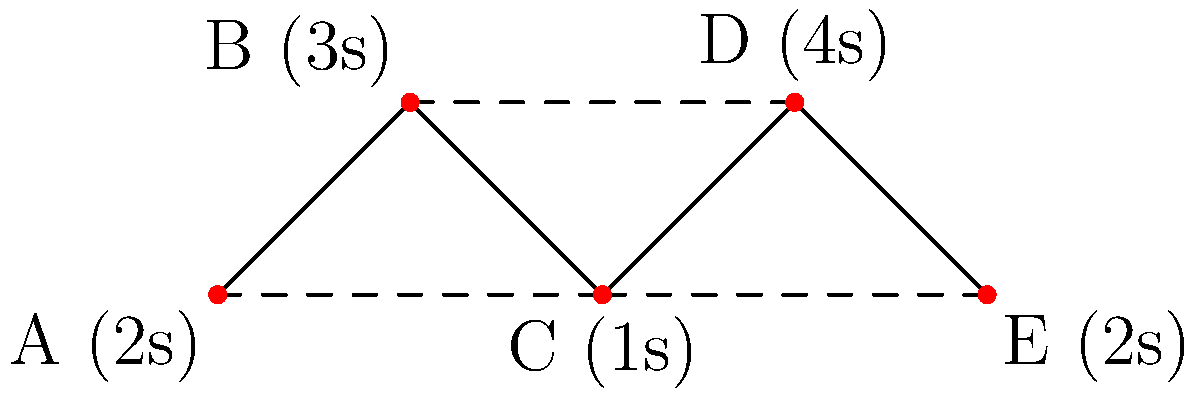Given the network graph representing a website's structure, where nodes represent pages and edges represent links between pages, and the load time for each page is given in parentheses, what is the minimum total load time required to visit all pages, starting from page A and ending at page E? To find the minimum total load time, we need to determine the shortest path that visits all pages from A to E. Let's break it down step-by-step:

1. Start at page A (2s load time)
2. We have two options from A: go to B or C
   - Path A-B-C: 2s + 3s + 1s = 6s
   - Path A-C: 2s + 1s = 3s
3. Choose the shorter path: A-C (3s total)
4. From C, we must visit both D and E
   - Path C-D-E: 1s + 4s + 2s = 7s
   - Path C-E-D: 1s + 2s + 4s = 7s
5. Both paths have the same total time, so we can choose either
6. Let's choose C-D-E for this example

The final path is A-C-D-E with the following calculation:
$$ \text{Total time} = t_A + t_C + t_D + t_E $$
$$ \text{Total time} = 2s + 1s + 4s + 2s = 9s $$

Therefore, the minimum total load time to visit all pages from A to E is 9 seconds.
Answer: 9 seconds 